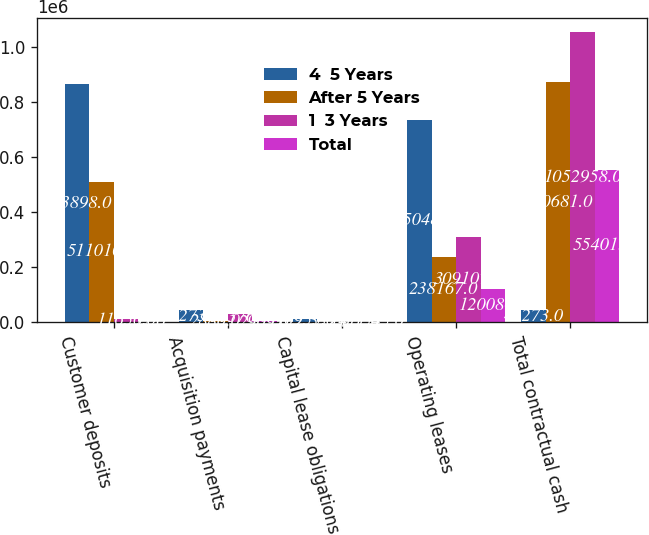Convert chart. <chart><loc_0><loc_0><loc_500><loc_500><stacked_bar_chart><ecel><fcel>Customer deposits<fcel>Acquisition payments<fcel>Capital lease obligations<fcel>Operating leases<fcel>Total contractual cash<nl><fcel>4  5 Years<fcel>863898<fcel>43273<fcel>10953<fcel>735048<fcel>43273<nl><fcel>After 5 Years<fcel>511010<fcel>2880<fcel>557<fcel>238167<fcel>870681<nl><fcel>1  3 Years<fcel>11656<fcel>31376<fcel>1411<fcel>309107<fcel>1.05296e+06<nl><fcel>Total<fcel>22<fcel>2909<fcel>1545<fcel>120080<fcel>554013<nl></chart> 